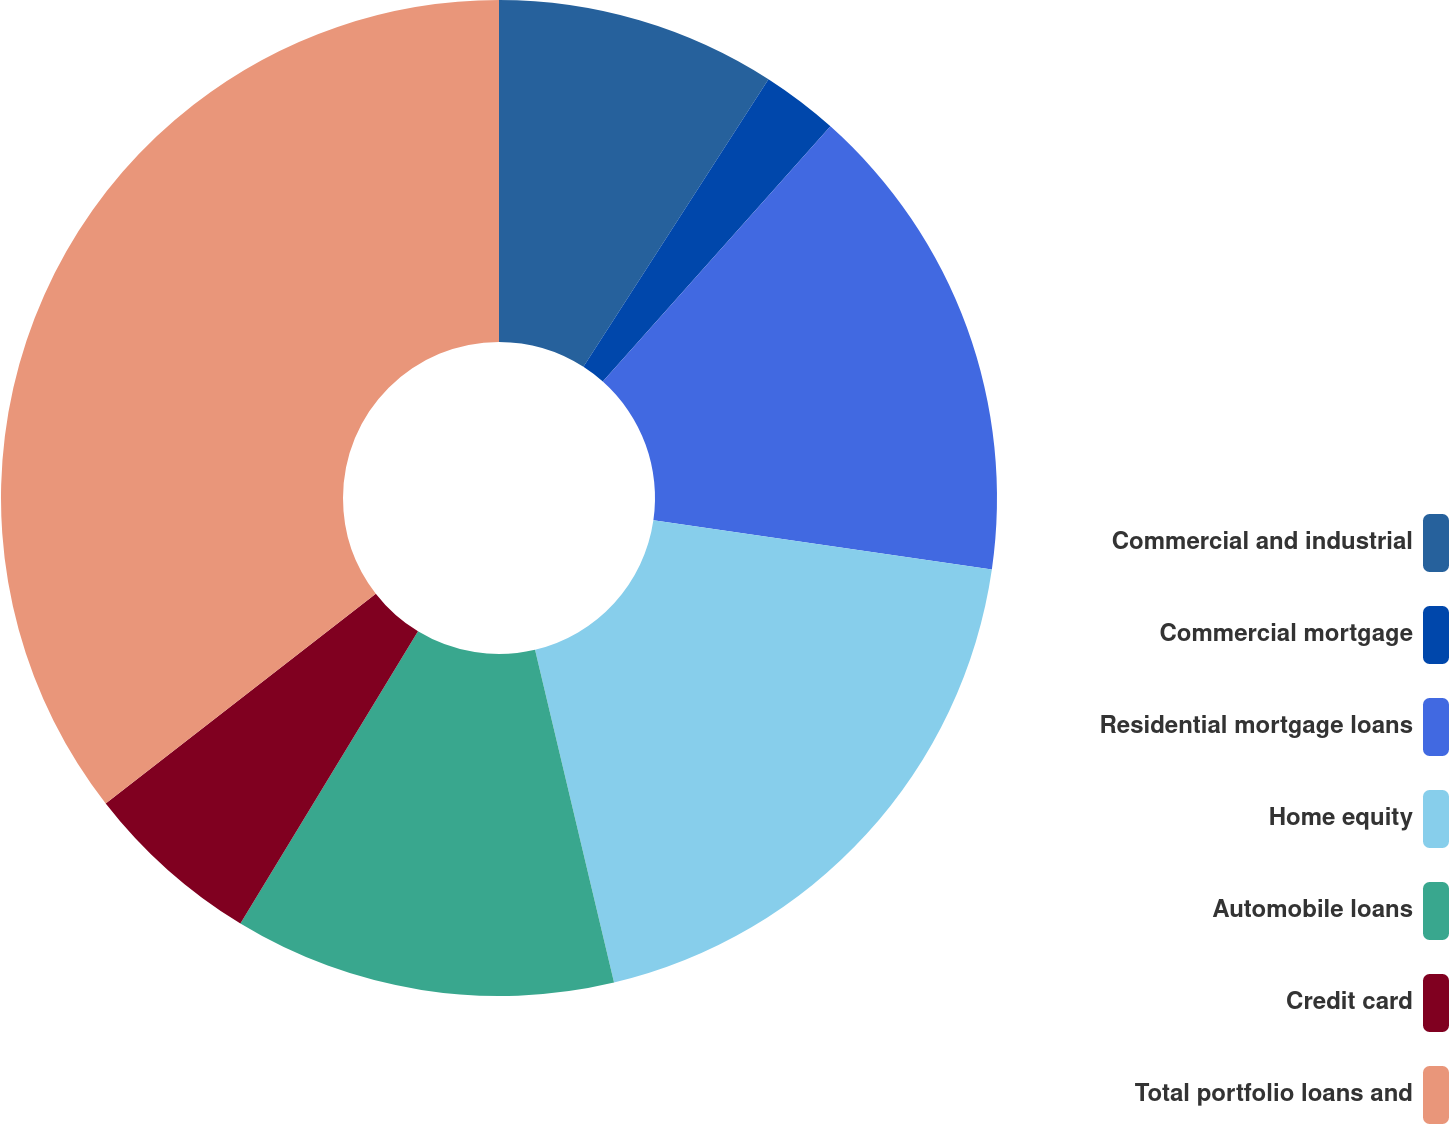<chart> <loc_0><loc_0><loc_500><loc_500><pie_chart><fcel>Commercial and industrial<fcel>Commercial mortgage<fcel>Residential mortgage loans<fcel>Home equity<fcel>Automobile loans<fcel>Credit card<fcel>Total portfolio loans and<nl><fcel>9.1%<fcel>2.49%<fcel>15.7%<fcel>19.0%<fcel>12.4%<fcel>5.8%<fcel>35.51%<nl></chart> 